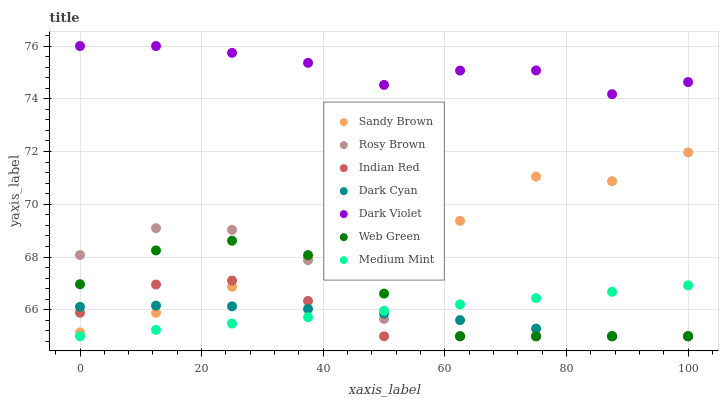Does Dark Cyan have the minimum area under the curve?
Answer yes or no. Yes. Does Dark Violet have the maximum area under the curve?
Answer yes or no. Yes. Does Rosy Brown have the minimum area under the curve?
Answer yes or no. No. Does Rosy Brown have the maximum area under the curve?
Answer yes or no. No. Is Medium Mint the smoothest?
Answer yes or no. Yes. Is Rosy Brown the roughest?
Answer yes or no. Yes. Is Web Green the smoothest?
Answer yes or no. No. Is Web Green the roughest?
Answer yes or no. No. Does Medium Mint have the lowest value?
Answer yes or no. Yes. Does Dark Violet have the lowest value?
Answer yes or no. No. Does Dark Violet have the highest value?
Answer yes or no. Yes. Does Rosy Brown have the highest value?
Answer yes or no. No. Is Dark Cyan less than Dark Violet?
Answer yes or no. Yes. Is Dark Violet greater than Rosy Brown?
Answer yes or no. Yes. Does Web Green intersect Medium Mint?
Answer yes or no. Yes. Is Web Green less than Medium Mint?
Answer yes or no. No. Is Web Green greater than Medium Mint?
Answer yes or no. No. Does Dark Cyan intersect Dark Violet?
Answer yes or no. No. 